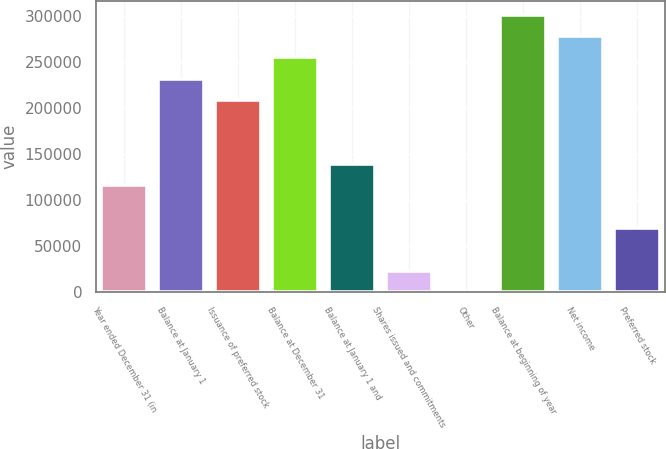Convert chart. <chart><loc_0><loc_0><loc_500><loc_500><bar_chart><fcel>Year ended December 31 (in<fcel>Balance at January 1<fcel>Issuance of preferred stock<fcel>Balance at December 31<fcel>Balance at January 1 and<fcel>Shares issued and commitments<fcel>Other<fcel>Balance at beginning of year<fcel>Net income<fcel>Preferred stock<nl><fcel>115888<fcel>231727<fcel>208559<fcel>254895<fcel>139056<fcel>23217.7<fcel>50<fcel>301230<fcel>278062<fcel>69553.1<nl></chart> 